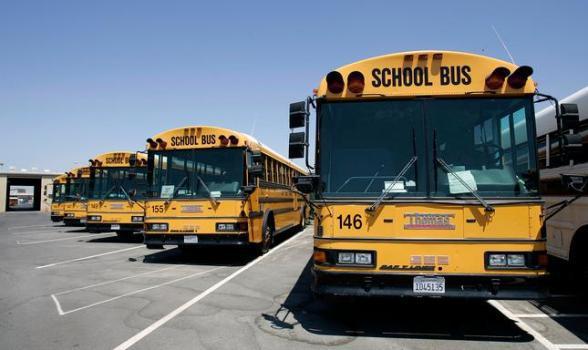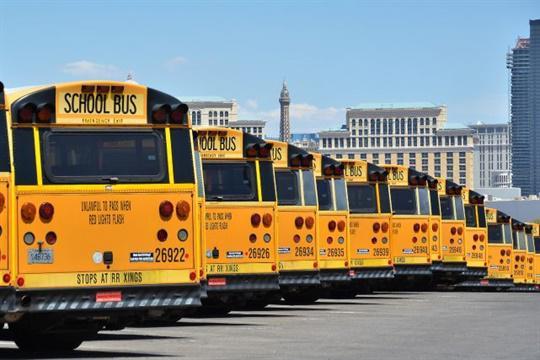The first image is the image on the left, the second image is the image on the right. Assess this claim about the two images: "A bus' passenger door is visible.". Correct or not? Answer yes or no. No. The first image is the image on the left, the second image is the image on the right. Considering the images on both sides, is "The buses on the right are parked in a row and facing toward the camera." valid? Answer yes or no. No. 